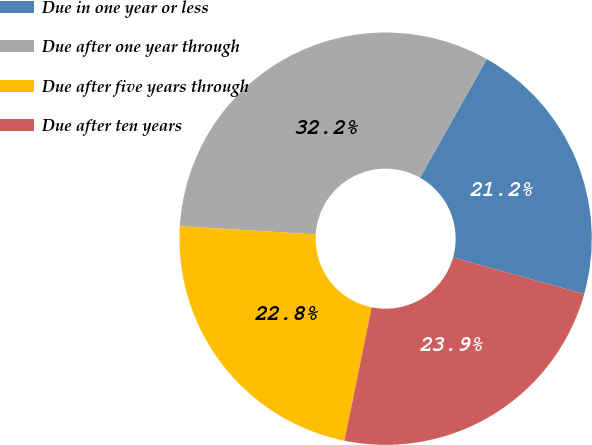<chart> <loc_0><loc_0><loc_500><loc_500><pie_chart><fcel>Due in one year or less<fcel>Due after one year through<fcel>Due after five years through<fcel>Due after ten years<nl><fcel>21.16%<fcel>32.2%<fcel>22.77%<fcel>23.88%<nl></chart> 